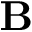<formula> <loc_0><loc_0><loc_500><loc_500>B</formula> 